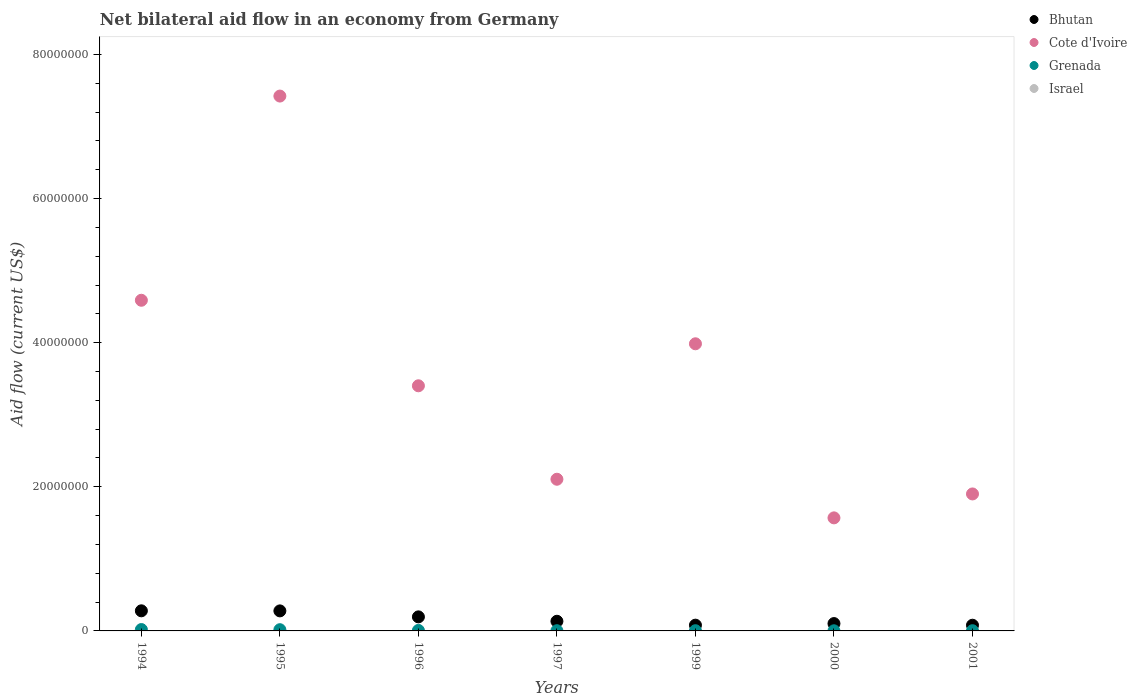How many different coloured dotlines are there?
Your answer should be very brief. 3. Is the number of dotlines equal to the number of legend labels?
Your answer should be compact. No. What is the net bilateral aid flow in Bhutan in 1994?
Ensure brevity in your answer.  2.79e+06. Across all years, what is the maximum net bilateral aid flow in Cote d'Ivoire?
Ensure brevity in your answer.  7.42e+07. Across all years, what is the minimum net bilateral aid flow in Bhutan?
Your answer should be compact. 7.90e+05. What is the total net bilateral aid flow in Bhutan in the graph?
Provide a short and direct response. 1.15e+07. What is the difference between the net bilateral aid flow in Cote d'Ivoire in 1999 and the net bilateral aid flow in Bhutan in 1996?
Give a very brief answer. 3.79e+07. What is the average net bilateral aid flow in Cote d'Ivoire per year?
Provide a short and direct response. 3.57e+07. In the year 1999, what is the difference between the net bilateral aid flow in Grenada and net bilateral aid flow in Cote d'Ivoire?
Keep it short and to the point. -3.98e+07. In how many years, is the net bilateral aid flow in Israel greater than 36000000 US$?
Your answer should be very brief. 0. What is the ratio of the net bilateral aid flow in Bhutan in 1994 to that in 1997?
Ensure brevity in your answer.  2.08. What is the difference between the highest and the second highest net bilateral aid flow in Bhutan?
Give a very brief answer. 10000. What is the difference between the highest and the lowest net bilateral aid flow in Cote d'Ivoire?
Your response must be concise. 5.85e+07. Is it the case that in every year, the sum of the net bilateral aid flow in Israel and net bilateral aid flow in Cote d'Ivoire  is greater than the net bilateral aid flow in Grenada?
Make the answer very short. Yes. Is the net bilateral aid flow in Bhutan strictly less than the net bilateral aid flow in Israel over the years?
Give a very brief answer. No. What is the difference between two consecutive major ticks on the Y-axis?
Provide a short and direct response. 2.00e+07. Are the values on the major ticks of Y-axis written in scientific E-notation?
Your answer should be very brief. No. Where does the legend appear in the graph?
Provide a short and direct response. Top right. How many legend labels are there?
Offer a terse response. 4. What is the title of the graph?
Your answer should be very brief. Net bilateral aid flow in an economy from Germany. What is the label or title of the X-axis?
Provide a succinct answer. Years. What is the label or title of the Y-axis?
Your response must be concise. Aid flow (current US$). What is the Aid flow (current US$) in Bhutan in 1994?
Give a very brief answer. 2.79e+06. What is the Aid flow (current US$) of Cote d'Ivoire in 1994?
Give a very brief answer. 4.59e+07. What is the Aid flow (current US$) in Israel in 1994?
Offer a very short reply. 0. What is the Aid flow (current US$) of Bhutan in 1995?
Give a very brief answer. 2.78e+06. What is the Aid flow (current US$) of Cote d'Ivoire in 1995?
Offer a very short reply. 7.42e+07. What is the Aid flow (current US$) of Grenada in 1995?
Give a very brief answer. 1.70e+05. What is the Aid flow (current US$) of Bhutan in 1996?
Your answer should be compact. 1.95e+06. What is the Aid flow (current US$) in Cote d'Ivoire in 1996?
Provide a short and direct response. 3.40e+07. What is the Aid flow (current US$) of Bhutan in 1997?
Keep it short and to the point. 1.34e+06. What is the Aid flow (current US$) of Cote d'Ivoire in 1997?
Offer a terse response. 2.10e+07. What is the Aid flow (current US$) in Grenada in 1997?
Give a very brief answer. 3.00e+04. What is the Aid flow (current US$) of Bhutan in 1999?
Make the answer very short. 8.00e+05. What is the Aid flow (current US$) of Cote d'Ivoire in 1999?
Give a very brief answer. 3.98e+07. What is the Aid flow (current US$) of Bhutan in 2000?
Provide a succinct answer. 1.02e+06. What is the Aid flow (current US$) in Cote d'Ivoire in 2000?
Provide a succinct answer. 1.57e+07. What is the Aid flow (current US$) in Israel in 2000?
Offer a terse response. 0. What is the Aid flow (current US$) in Bhutan in 2001?
Provide a short and direct response. 7.90e+05. What is the Aid flow (current US$) of Cote d'Ivoire in 2001?
Provide a short and direct response. 1.90e+07. Across all years, what is the maximum Aid flow (current US$) in Bhutan?
Offer a very short reply. 2.79e+06. Across all years, what is the maximum Aid flow (current US$) of Cote d'Ivoire?
Provide a short and direct response. 7.42e+07. Across all years, what is the minimum Aid flow (current US$) in Bhutan?
Give a very brief answer. 7.90e+05. Across all years, what is the minimum Aid flow (current US$) in Cote d'Ivoire?
Offer a very short reply. 1.57e+07. Across all years, what is the minimum Aid flow (current US$) of Grenada?
Provide a short and direct response. 2.00e+04. What is the total Aid flow (current US$) in Bhutan in the graph?
Ensure brevity in your answer.  1.15e+07. What is the total Aid flow (current US$) of Cote d'Ivoire in the graph?
Your answer should be compact. 2.50e+08. What is the total Aid flow (current US$) in Grenada in the graph?
Make the answer very short. 5.40e+05. What is the difference between the Aid flow (current US$) of Cote d'Ivoire in 1994 and that in 1995?
Keep it short and to the point. -2.83e+07. What is the difference between the Aid flow (current US$) in Bhutan in 1994 and that in 1996?
Provide a succinct answer. 8.40e+05. What is the difference between the Aid flow (current US$) of Cote d'Ivoire in 1994 and that in 1996?
Give a very brief answer. 1.19e+07. What is the difference between the Aid flow (current US$) in Grenada in 1994 and that in 1996?
Keep it short and to the point. 1.20e+05. What is the difference between the Aid flow (current US$) of Bhutan in 1994 and that in 1997?
Ensure brevity in your answer.  1.45e+06. What is the difference between the Aid flow (current US$) of Cote d'Ivoire in 1994 and that in 1997?
Ensure brevity in your answer.  2.48e+07. What is the difference between the Aid flow (current US$) in Grenada in 1994 and that in 1997?
Make the answer very short. 1.60e+05. What is the difference between the Aid flow (current US$) of Bhutan in 1994 and that in 1999?
Provide a succinct answer. 1.99e+06. What is the difference between the Aid flow (current US$) of Cote d'Ivoire in 1994 and that in 1999?
Your response must be concise. 6.04e+06. What is the difference between the Aid flow (current US$) of Bhutan in 1994 and that in 2000?
Your answer should be very brief. 1.77e+06. What is the difference between the Aid flow (current US$) of Cote d'Ivoire in 1994 and that in 2000?
Offer a terse response. 3.02e+07. What is the difference between the Aid flow (current US$) in Grenada in 1994 and that in 2000?
Offer a terse response. 1.70e+05. What is the difference between the Aid flow (current US$) of Bhutan in 1994 and that in 2001?
Offer a very short reply. 2.00e+06. What is the difference between the Aid flow (current US$) in Cote d'Ivoire in 1994 and that in 2001?
Make the answer very short. 2.69e+07. What is the difference between the Aid flow (current US$) of Bhutan in 1995 and that in 1996?
Give a very brief answer. 8.30e+05. What is the difference between the Aid flow (current US$) in Cote d'Ivoire in 1995 and that in 1996?
Provide a short and direct response. 4.02e+07. What is the difference between the Aid flow (current US$) in Bhutan in 1995 and that in 1997?
Your response must be concise. 1.44e+06. What is the difference between the Aid flow (current US$) of Cote d'Ivoire in 1995 and that in 1997?
Ensure brevity in your answer.  5.32e+07. What is the difference between the Aid flow (current US$) in Grenada in 1995 and that in 1997?
Your answer should be very brief. 1.40e+05. What is the difference between the Aid flow (current US$) in Bhutan in 1995 and that in 1999?
Your response must be concise. 1.98e+06. What is the difference between the Aid flow (current US$) of Cote d'Ivoire in 1995 and that in 1999?
Your answer should be compact. 3.44e+07. What is the difference between the Aid flow (current US$) in Bhutan in 1995 and that in 2000?
Make the answer very short. 1.76e+06. What is the difference between the Aid flow (current US$) of Cote d'Ivoire in 1995 and that in 2000?
Offer a very short reply. 5.85e+07. What is the difference between the Aid flow (current US$) of Bhutan in 1995 and that in 2001?
Your answer should be very brief. 1.99e+06. What is the difference between the Aid flow (current US$) in Cote d'Ivoire in 1995 and that in 2001?
Your answer should be very brief. 5.52e+07. What is the difference between the Aid flow (current US$) of Bhutan in 1996 and that in 1997?
Provide a short and direct response. 6.10e+05. What is the difference between the Aid flow (current US$) in Cote d'Ivoire in 1996 and that in 1997?
Give a very brief answer. 1.30e+07. What is the difference between the Aid flow (current US$) of Bhutan in 1996 and that in 1999?
Give a very brief answer. 1.15e+06. What is the difference between the Aid flow (current US$) in Cote d'Ivoire in 1996 and that in 1999?
Your answer should be compact. -5.83e+06. What is the difference between the Aid flow (current US$) in Grenada in 1996 and that in 1999?
Provide a short and direct response. 4.00e+04. What is the difference between the Aid flow (current US$) of Bhutan in 1996 and that in 2000?
Provide a short and direct response. 9.30e+05. What is the difference between the Aid flow (current US$) of Cote d'Ivoire in 1996 and that in 2000?
Provide a succinct answer. 1.83e+07. What is the difference between the Aid flow (current US$) in Grenada in 1996 and that in 2000?
Offer a very short reply. 5.00e+04. What is the difference between the Aid flow (current US$) in Bhutan in 1996 and that in 2001?
Ensure brevity in your answer.  1.16e+06. What is the difference between the Aid flow (current US$) of Cote d'Ivoire in 1996 and that in 2001?
Ensure brevity in your answer.  1.50e+07. What is the difference between the Aid flow (current US$) in Grenada in 1996 and that in 2001?
Your answer should be compact. 4.00e+04. What is the difference between the Aid flow (current US$) of Bhutan in 1997 and that in 1999?
Ensure brevity in your answer.  5.40e+05. What is the difference between the Aid flow (current US$) in Cote d'Ivoire in 1997 and that in 1999?
Your answer should be very brief. -1.88e+07. What is the difference between the Aid flow (current US$) in Grenada in 1997 and that in 1999?
Your answer should be very brief. 0. What is the difference between the Aid flow (current US$) of Cote d'Ivoire in 1997 and that in 2000?
Make the answer very short. 5.36e+06. What is the difference between the Aid flow (current US$) in Grenada in 1997 and that in 2000?
Make the answer very short. 10000. What is the difference between the Aid flow (current US$) of Cote d'Ivoire in 1997 and that in 2001?
Make the answer very short. 2.04e+06. What is the difference between the Aid flow (current US$) in Grenada in 1997 and that in 2001?
Offer a terse response. 0. What is the difference between the Aid flow (current US$) in Cote d'Ivoire in 1999 and that in 2000?
Offer a very short reply. 2.42e+07. What is the difference between the Aid flow (current US$) of Cote d'Ivoire in 1999 and that in 2001?
Offer a terse response. 2.08e+07. What is the difference between the Aid flow (current US$) in Grenada in 1999 and that in 2001?
Ensure brevity in your answer.  0. What is the difference between the Aid flow (current US$) in Cote d'Ivoire in 2000 and that in 2001?
Offer a terse response. -3.32e+06. What is the difference between the Aid flow (current US$) of Grenada in 2000 and that in 2001?
Offer a terse response. -10000. What is the difference between the Aid flow (current US$) in Bhutan in 1994 and the Aid flow (current US$) in Cote d'Ivoire in 1995?
Offer a very short reply. -7.14e+07. What is the difference between the Aid flow (current US$) of Bhutan in 1994 and the Aid flow (current US$) of Grenada in 1995?
Keep it short and to the point. 2.62e+06. What is the difference between the Aid flow (current US$) in Cote d'Ivoire in 1994 and the Aid flow (current US$) in Grenada in 1995?
Provide a succinct answer. 4.57e+07. What is the difference between the Aid flow (current US$) of Bhutan in 1994 and the Aid flow (current US$) of Cote d'Ivoire in 1996?
Provide a succinct answer. -3.12e+07. What is the difference between the Aid flow (current US$) of Bhutan in 1994 and the Aid flow (current US$) of Grenada in 1996?
Make the answer very short. 2.72e+06. What is the difference between the Aid flow (current US$) in Cote d'Ivoire in 1994 and the Aid flow (current US$) in Grenada in 1996?
Ensure brevity in your answer.  4.58e+07. What is the difference between the Aid flow (current US$) of Bhutan in 1994 and the Aid flow (current US$) of Cote d'Ivoire in 1997?
Your response must be concise. -1.83e+07. What is the difference between the Aid flow (current US$) of Bhutan in 1994 and the Aid flow (current US$) of Grenada in 1997?
Offer a terse response. 2.76e+06. What is the difference between the Aid flow (current US$) of Cote d'Ivoire in 1994 and the Aid flow (current US$) of Grenada in 1997?
Your answer should be very brief. 4.59e+07. What is the difference between the Aid flow (current US$) in Bhutan in 1994 and the Aid flow (current US$) in Cote d'Ivoire in 1999?
Make the answer very short. -3.71e+07. What is the difference between the Aid flow (current US$) in Bhutan in 1994 and the Aid flow (current US$) in Grenada in 1999?
Offer a terse response. 2.76e+06. What is the difference between the Aid flow (current US$) in Cote d'Ivoire in 1994 and the Aid flow (current US$) in Grenada in 1999?
Provide a short and direct response. 4.59e+07. What is the difference between the Aid flow (current US$) in Bhutan in 1994 and the Aid flow (current US$) in Cote d'Ivoire in 2000?
Offer a terse response. -1.29e+07. What is the difference between the Aid flow (current US$) of Bhutan in 1994 and the Aid flow (current US$) of Grenada in 2000?
Ensure brevity in your answer.  2.77e+06. What is the difference between the Aid flow (current US$) in Cote d'Ivoire in 1994 and the Aid flow (current US$) in Grenada in 2000?
Your response must be concise. 4.59e+07. What is the difference between the Aid flow (current US$) of Bhutan in 1994 and the Aid flow (current US$) of Cote d'Ivoire in 2001?
Give a very brief answer. -1.62e+07. What is the difference between the Aid flow (current US$) in Bhutan in 1994 and the Aid flow (current US$) in Grenada in 2001?
Your answer should be compact. 2.76e+06. What is the difference between the Aid flow (current US$) in Cote d'Ivoire in 1994 and the Aid flow (current US$) in Grenada in 2001?
Provide a short and direct response. 4.59e+07. What is the difference between the Aid flow (current US$) in Bhutan in 1995 and the Aid flow (current US$) in Cote d'Ivoire in 1996?
Provide a succinct answer. -3.12e+07. What is the difference between the Aid flow (current US$) of Bhutan in 1995 and the Aid flow (current US$) of Grenada in 1996?
Offer a very short reply. 2.71e+06. What is the difference between the Aid flow (current US$) in Cote d'Ivoire in 1995 and the Aid flow (current US$) in Grenada in 1996?
Your answer should be very brief. 7.42e+07. What is the difference between the Aid flow (current US$) of Bhutan in 1995 and the Aid flow (current US$) of Cote d'Ivoire in 1997?
Provide a succinct answer. -1.83e+07. What is the difference between the Aid flow (current US$) in Bhutan in 1995 and the Aid flow (current US$) in Grenada in 1997?
Give a very brief answer. 2.75e+06. What is the difference between the Aid flow (current US$) of Cote d'Ivoire in 1995 and the Aid flow (current US$) of Grenada in 1997?
Your answer should be very brief. 7.42e+07. What is the difference between the Aid flow (current US$) of Bhutan in 1995 and the Aid flow (current US$) of Cote d'Ivoire in 1999?
Provide a succinct answer. -3.71e+07. What is the difference between the Aid flow (current US$) in Bhutan in 1995 and the Aid flow (current US$) in Grenada in 1999?
Make the answer very short. 2.75e+06. What is the difference between the Aid flow (current US$) in Cote d'Ivoire in 1995 and the Aid flow (current US$) in Grenada in 1999?
Your response must be concise. 7.42e+07. What is the difference between the Aid flow (current US$) in Bhutan in 1995 and the Aid flow (current US$) in Cote d'Ivoire in 2000?
Give a very brief answer. -1.29e+07. What is the difference between the Aid flow (current US$) in Bhutan in 1995 and the Aid flow (current US$) in Grenada in 2000?
Make the answer very short. 2.76e+06. What is the difference between the Aid flow (current US$) in Cote d'Ivoire in 1995 and the Aid flow (current US$) in Grenada in 2000?
Make the answer very short. 7.42e+07. What is the difference between the Aid flow (current US$) of Bhutan in 1995 and the Aid flow (current US$) of Cote d'Ivoire in 2001?
Ensure brevity in your answer.  -1.62e+07. What is the difference between the Aid flow (current US$) of Bhutan in 1995 and the Aid flow (current US$) of Grenada in 2001?
Keep it short and to the point. 2.75e+06. What is the difference between the Aid flow (current US$) of Cote d'Ivoire in 1995 and the Aid flow (current US$) of Grenada in 2001?
Give a very brief answer. 7.42e+07. What is the difference between the Aid flow (current US$) in Bhutan in 1996 and the Aid flow (current US$) in Cote d'Ivoire in 1997?
Your response must be concise. -1.91e+07. What is the difference between the Aid flow (current US$) in Bhutan in 1996 and the Aid flow (current US$) in Grenada in 1997?
Your answer should be very brief. 1.92e+06. What is the difference between the Aid flow (current US$) in Cote d'Ivoire in 1996 and the Aid flow (current US$) in Grenada in 1997?
Offer a terse response. 3.40e+07. What is the difference between the Aid flow (current US$) of Bhutan in 1996 and the Aid flow (current US$) of Cote d'Ivoire in 1999?
Ensure brevity in your answer.  -3.79e+07. What is the difference between the Aid flow (current US$) of Bhutan in 1996 and the Aid flow (current US$) of Grenada in 1999?
Make the answer very short. 1.92e+06. What is the difference between the Aid flow (current US$) in Cote d'Ivoire in 1996 and the Aid flow (current US$) in Grenada in 1999?
Give a very brief answer. 3.40e+07. What is the difference between the Aid flow (current US$) of Bhutan in 1996 and the Aid flow (current US$) of Cote d'Ivoire in 2000?
Provide a short and direct response. -1.37e+07. What is the difference between the Aid flow (current US$) of Bhutan in 1996 and the Aid flow (current US$) of Grenada in 2000?
Give a very brief answer. 1.93e+06. What is the difference between the Aid flow (current US$) of Cote d'Ivoire in 1996 and the Aid flow (current US$) of Grenada in 2000?
Offer a terse response. 3.40e+07. What is the difference between the Aid flow (current US$) of Bhutan in 1996 and the Aid flow (current US$) of Cote d'Ivoire in 2001?
Your answer should be very brief. -1.71e+07. What is the difference between the Aid flow (current US$) in Bhutan in 1996 and the Aid flow (current US$) in Grenada in 2001?
Ensure brevity in your answer.  1.92e+06. What is the difference between the Aid flow (current US$) of Cote d'Ivoire in 1996 and the Aid flow (current US$) of Grenada in 2001?
Offer a terse response. 3.40e+07. What is the difference between the Aid flow (current US$) in Bhutan in 1997 and the Aid flow (current US$) in Cote d'Ivoire in 1999?
Your answer should be compact. -3.85e+07. What is the difference between the Aid flow (current US$) in Bhutan in 1997 and the Aid flow (current US$) in Grenada in 1999?
Make the answer very short. 1.31e+06. What is the difference between the Aid flow (current US$) of Cote d'Ivoire in 1997 and the Aid flow (current US$) of Grenada in 1999?
Offer a very short reply. 2.10e+07. What is the difference between the Aid flow (current US$) in Bhutan in 1997 and the Aid flow (current US$) in Cote d'Ivoire in 2000?
Your answer should be compact. -1.44e+07. What is the difference between the Aid flow (current US$) of Bhutan in 1997 and the Aid flow (current US$) of Grenada in 2000?
Provide a short and direct response. 1.32e+06. What is the difference between the Aid flow (current US$) in Cote d'Ivoire in 1997 and the Aid flow (current US$) in Grenada in 2000?
Your response must be concise. 2.10e+07. What is the difference between the Aid flow (current US$) in Bhutan in 1997 and the Aid flow (current US$) in Cote d'Ivoire in 2001?
Provide a succinct answer. -1.77e+07. What is the difference between the Aid flow (current US$) of Bhutan in 1997 and the Aid flow (current US$) of Grenada in 2001?
Give a very brief answer. 1.31e+06. What is the difference between the Aid flow (current US$) in Cote d'Ivoire in 1997 and the Aid flow (current US$) in Grenada in 2001?
Your answer should be very brief. 2.10e+07. What is the difference between the Aid flow (current US$) of Bhutan in 1999 and the Aid flow (current US$) of Cote d'Ivoire in 2000?
Your answer should be compact. -1.49e+07. What is the difference between the Aid flow (current US$) of Bhutan in 1999 and the Aid flow (current US$) of Grenada in 2000?
Make the answer very short. 7.80e+05. What is the difference between the Aid flow (current US$) in Cote d'Ivoire in 1999 and the Aid flow (current US$) in Grenada in 2000?
Provide a short and direct response. 3.98e+07. What is the difference between the Aid flow (current US$) of Bhutan in 1999 and the Aid flow (current US$) of Cote d'Ivoire in 2001?
Your response must be concise. -1.82e+07. What is the difference between the Aid flow (current US$) of Bhutan in 1999 and the Aid flow (current US$) of Grenada in 2001?
Make the answer very short. 7.70e+05. What is the difference between the Aid flow (current US$) of Cote d'Ivoire in 1999 and the Aid flow (current US$) of Grenada in 2001?
Offer a terse response. 3.98e+07. What is the difference between the Aid flow (current US$) in Bhutan in 2000 and the Aid flow (current US$) in Cote d'Ivoire in 2001?
Your answer should be very brief. -1.80e+07. What is the difference between the Aid flow (current US$) in Bhutan in 2000 and the Aid flow (current US$) in Grenada in 2001?
Your answer should be very brief. 9.90e+05. What is the difference between the Aid flow (current US$) of Cote d'Ivoire in 2000 and the Aid flow (current US$) of Grenada in 2001?
Give a very brief answer. 1.57e+07. What is the average Aid flow (current US$) of Bhutan per year?
Provide a succinct answer. 1.64e+06. What is the average Aid flow (current US$) of Cote d'Ivoire per year?
Ensure brevity in your answer.  3.57e+07. What is the average Aid flow (current US$) of Grenada per year?
Your answer should be compact. 7.71e+04. What is the average Aid flow (current US$) in Israel per year?
Ensure brevity in your answer.  0. In the year 1994, what is the difference between the Aid flow (current US$) of Bhutan and Aid flow (current US$) of Cote d'Ivoire?
Make the answer very short. -4.31e+07. In the year 1994, what is the difference between the Aid flow (current US$) of Bhutan and Aid flow (current US$) of Grenada?
Your answer should be compact. 2.60e+06. In the year 1994, what is the difference between the Aid flow (current US$) of Cote d'Ivoire and Aid flow (current US$) of Grenada?
Offer a very short reply. 4.57e+07. In the year 1995, what is the difference between the Aid flow (current US$) of Bhutan and Aid flow (current US$) of Cote d'Ivoire?
Your response must be concise. -7.14e+07. In the year 1995, what is the difference between the Aid flow (current US$) in Bhutan and Aid flow (current US$) in Grenada?
Keep it short and to the point. 2.61e+06. In the year 1995, what is the difference between the Aid flow (current US$) of Cote d'Ivoire and Aid flow (current US$) of Grenada?
Your response must be concise. 7.41e+07. In the year 1996, what is the difference between the Aid flow (current US$) in Bhutan and Aid flow (current US$) in Cote d'Ivoire?
Your answer should be compact. -3.21e+07. In the year 1996, what is the difference between the Aid flow (current US$) of Bhutan and Aid flow (current US$) of Grenada?
Give a very brief answer. 1.88e+06. In the year 1996, what is the difference between the Aid flow (current US$) of Cote d'Ivoire and Aid flow (current US$) of Grenada?
Ensure brevity in your answer.  3.40e+07. In the year 1997, what is the difference between the Aid flow (current US$) of Bhutan and Aid flow (current US$) of Cote d'Ivoire?
Your response must be concise. -1.97e+07. In the year 1997, what is the difference between the Aid flow (current US$) in Bhutan and Aid flow (current US$) in Grenada?
Your response must be concise. 1.31e+06. In the year 1997, what is the difference between the Aid flow (current US$) in Cote d'Ivoire and Aid flow (current US$) in Grenada?
Your answer should be compact. 2.10e+07. In the year 1999, what is the difference between the Aid flow (current US$) of Bhutan and Aid flow (current US$) of Cote d'Ivoire?
Provide a short and direct response. -3.90e+07. In the year 1999, what is the difference between the Aid flow (current US$) in Bhutan and Aid flow (current US$) in Grenada?
Your answer should be very brief. 7.70e+05. In the year 1999, what is the difference between the Aid flow (current US$) of Cote d'Ivoire and Aid flow (current US$) of Grenada?
Give a very brief answer. 3.98e+07. In the year 2000, what is the difference between the Aid flow (current US$) of Bhutan and Aid flow (current US$) of Cote d'Ivoire?
Your response must be concise. -1.47e+07. In the year 2000, what is the difference between the Aid flow (current US$) in Bhutan and Aid flow (current US$) in Grenada?
Your answer should be very brief. 1.00e+06. In the year 2000, what is the difference between the Aid flow (current US$) of Cote d'Ivoire and Aid flow (current US$) of Grenada?
Keep it short and to the point. 1.57e+07. In the year 2001, what is the difference between the Aid flow (current US$) in Bhutan and Aid flow (current US$) in Cote d'Ivoire?
Keep it short and to the point. -1.82e+07. In the year 2001, what is the difference between the Aid flow (current US$) in Bhutan and Aid flow (current US$) in Grenada?
Make the answer very short. 7.60e+05. In the year 2001, what is the difference between the Aid flow (current US$) of Cote d'Ivoire and Aid flow (current US$) of Grenada?
Keep it short and to the point. 1.90e+07. What is the ratio of the Aid flow (current US$) in Cote d'Ivoire in 1994 to that in 1995?
Keep it short and to the point. 0.62. What is the ratio of the Aid flow (current US$) of Grenada in 1994 to that in 1995?
Offer a very short reply. 1.12. What is the ratio of the Aid flow (current US$) in Bhutan in 1994 to that in 1996?
Make the answer very short. 1.43. What is the ratio of the Aid flow (current US$) of Cote d'Ivoire in 1994 to that in 1996?
Give a very brief answer. 1.35. What is the ratio of the Aid flow (current US$) of Grenada in 1994 to that in 1996?
Your answer should be very brief. 2.71. What is the ratio of the Aid flow (current US$) in Bhutan in 1994 to that in 1997?
Give a very brief answer. 2.08. What is the ratio of the Aid flow (current US$) in Cote d'Ivoire in 1994 to that in 1997?
Offer a very short reply. 2.18. What is the ratio of the Aid flow (current US$) of Grenada in 1994 to that in 1997?
Keep it short and to the point. 6.33. What is the ratio of the Aid flow (current US$) of Bhutan in 1994 to that in 1999?
Offer a very short reply. 3.49. What is the ratio of the Aid flow (current US$) of Cote d'Ivoire in 1994 to that in 1999?
Your response must be concise. 1.15. What is the ratio of the Aid flow (current US$) of Grenada in 1994 to that in 1999?
Your answer should be compact. 6.33. What is the ratio of the Aid flow (current US$) in Bhutan in 1994 to that in 2000?
Your answer should be compact. 2.74. What is the ratio of the Aid flow (current US$) of Cote d'Ivoire in 1994 to that in 2000?
Provide a succinct answer. 2.92. What is the ratio of the Aid flow (current US$) in Bhutan in 1994 to that in 2001?
Offer a terse response. 3.53. What is the ratio of the Aid flow (current US$) in Cote d'Ivoire in 1994 to that in 2001?
Provide a short and direct response. 2.41. What is the ratio of the Aid flow (current US$) of Grenada in 1994 to that in 2001?
Your response must be concise. 6.33. What is the ratio of the Aid flow (current US$) of Bhutan in 1995 to that in 1996?
Give a very brief answer. 1.43. What is the ratio of the Aid flow (current US$) of Cote d'Ivoire in 1995 to that in 1996?
Offer a very short reply. 2.18. What is the ratio of the Aid flow (current US$) in Grenada in 1995 to that in 1996?
Your answer should be very brief. 2.43. What is the ratio of the Aid flow (current US$) in Bhutan in 1995 to that in 1997?
Provide a succinct answer. 2.07. What is the ratio of the Aid flow (current US$) in Cote d'Ivoire in 1995 to that in 1997?
Offer a very short reply. 3.53. What is the ratio of the Aid flow (current US$) in Grenada in 1995 to that in 1997?
Your answer should be compact. 5.67. What is the ratio of the Aid flow (current US$) in Bhutan in 1995 to that in 1999?
Ensure brevity in your answer.  3.48. What is the ratio of the Aid flow (current US$) of Cote d'Ivoire in 1995 to that in 1999?
Make the answer very short. 1.86. What is the ratio of the Aid flow (current US$) of Grenada in 1995 to that in 1999?
Your answer should be very brief. 5.67. What is the ratio of the Aid flow (current US$) in Bhutan in 1995 to that in 2000?
Your answer should be compact. 2.73. What is the ratio of the Aid flow (current US$) in Cote d'Ivoire in 1995 to that in 2000?
Your answer should be compact. 4.73. What is the ratio of the Aid flow (current US$) of Bhutan in 1995 to that in 2001?
Make the answer very short. 3.52. What is the ratio of the Aid flow (current US$) of Cote d'Ivoire in 1995 to that in 2001?
Provide a short and direct response. 3.9. What is the ratio of the Aid flow (current US$) in Grenada in 1995 to that in 2001?
Provide a short and direct response. 5.67. What is the ratio of the Aid flow (current US$) in Bhutan in 1996 to that in 1997?
Your response must be concise. 1.46. What is the ratio of the Aid flow (current US$) in Cote d'Ivoire in 1996 to that in 1997?
Provide a succinct answer. 1.62. What is the ratio of the Aid flow (current US$) in Grenada in 1996 to that in 1997?
Provide a succinct answer. 2.33. What is the ratio of the Aid flow (current US$) in Bhutan in 1996 to that in 1999?
Ensure brevity in your answer.  2.44. What is the ratio of the Aid flow (current US$) in Cote d'Ivoire in 1996 to that in 1999?
Offer a terse response. 0.85. What is the ratio of the Aid flow (current US$) in Grenada in 1996 to that in 1999?
Make the answer very short. 2.33. What is the ratio of the Aid flow (current US$) of Bhutan in 1996 to that in 2000?
Provide a succinct answer. 1.91. What is the ratio of the Aid flow (current US$) in Cote d'Ivoire in 1996 to that in 2000?
Your response must be concise. 2.17. What is the ratio of the Aid flow (current US$) of Grenada in 1996 to that in 2000?
Your answer should be very brief. 3.5. What is the ratio of the Aid flow (current US$) in Bhutan in 1996 to that in 2001?
Your response must be concise. 2.47. What is the ratio of the Aid flow (current US$) of Cote d'Ivoire in 1996 to that in 2001?
Provide a succinct answer. 1.79. What is the ratio of the Aid flow (current US$) in Grenada in 1996 to that in 2001?
Offer a terse response. 2.33. What is the ratio of the Aid flow (current US$) of Bhutan in 1997 to that in 1999?
Provide a short and direct response. 1.68. What is the ratio of the Aid flow (current US$) of Cote d'Ivoire in 1997 to that in 1999?
Ensure brevity in your answer.  0.53. What is the ratio of the Aid flow (current US$) of Bhutan in 1997 to that in 2000?
Provide a succinct answer. 1.31. What is the ratio of the Aid flow (current US$) in Cote d'Ivoire in 1997 to that in 2000?
Provide a short and direct response. 1.34. What is the ratio of the Aid flow (current US$) of Grenada in 1997 to that in 2000?
Your answer should be very brief. 1.5. What is the ratio of the Aid flow (current US$) of Bhutan in 1997 to that in 2001?
Keep it short and to the point. 1.7. What is the ratio of the Aid flow (current US$) in Cote d'Ivoire in 1997 to that in 2001?
Provide a short and direct response. 1.11. What is the ratio of the Aid flow (current US$) in Bhutan in 1999 to that in 2000?
Give a very brief answer. 0.78. What is the ratio of the Aid flow (current US$) of Cote d'Ivoire in 1999 to that in 2000?
Give a very brief answer. 2.54. What is the ratio of the Aid flow (current US$) in Bhutan in 1999 to that in 2001?
Offer a terse response. 1.01. What is the ratio of the Aid flow (current US$) in Cote d'Ivoire in 1999 to that in 2001?
Provide a short and direct response. 2.1. What is the ratio of the Aid flow (current US$) in Grenada in 1999 to that in 2001?
Ensure brevity in your answer.  1. What is the ratio of the Aid flow (current US$) in Bhutan in 2000 to that in 2001?
Ensure brevity in your answer.  1.29. What is the ratio of the Aid flow (current US$) of Cote d'Ivoire in 2000 to that in 2001?
Your response must be concise. 0.83. What is the difference between the highest and the second highest Aid flow (current US$) in Cote d'Ivoire?
Your answer should be very brief. 2.83e+07. What is the difference between the highest and the lowest Aid flow (current US$) of Cote d'Ivoire?
Your response must be concise. 5.85e+07. What is the difference between the highest and the lowest Aid flow (current US$) of Grenada?
Ensure brevity in your answer.  1.70e+05. 